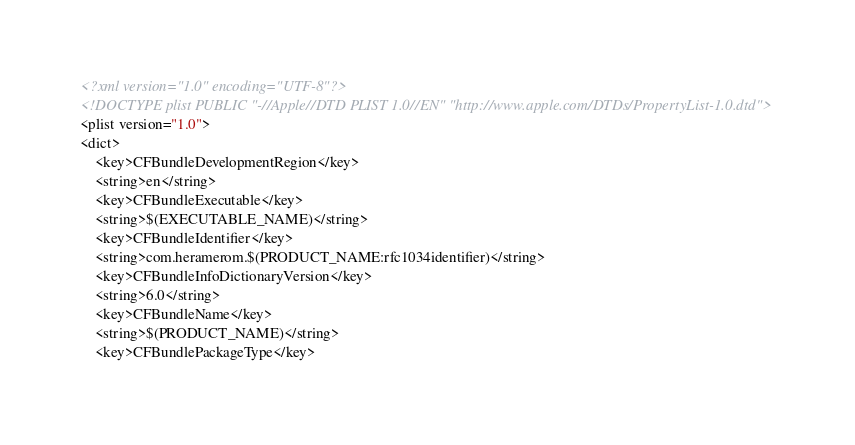Convert code to text. <code><loc_0><loc_0><loc_500><loc_500><_XML_><?xml version="1.0" encoding="UTF-8"?>
<!DOCTYPE plist PUBLIC "-//Apple//DTD PLIST 1.0//EN" "http://www.apple.com/DTDs/PropertyList-1.0.dtd">
<plist version="1.0">
<dict>
	<key>CFBundleDevelopmentRegion</key>
	<string>en</string>
	<key>CFBundleExecutable</key>
	<string>$(EXECUTABLE_NAME)</string>
	<key>CFBundleIdentifier</key>
	<string>com.heramerom.$(PRODUCT_NAME:rfc1034identifier)</string>
	<key>CFBundleInfoDictionaryVersion</key>
	<string>6.0</string>
	<key>CFBundleName</key>
	<string>$(PRODUCT_NAME)</string>
	<key>CFBundlePackageType</key></code> 